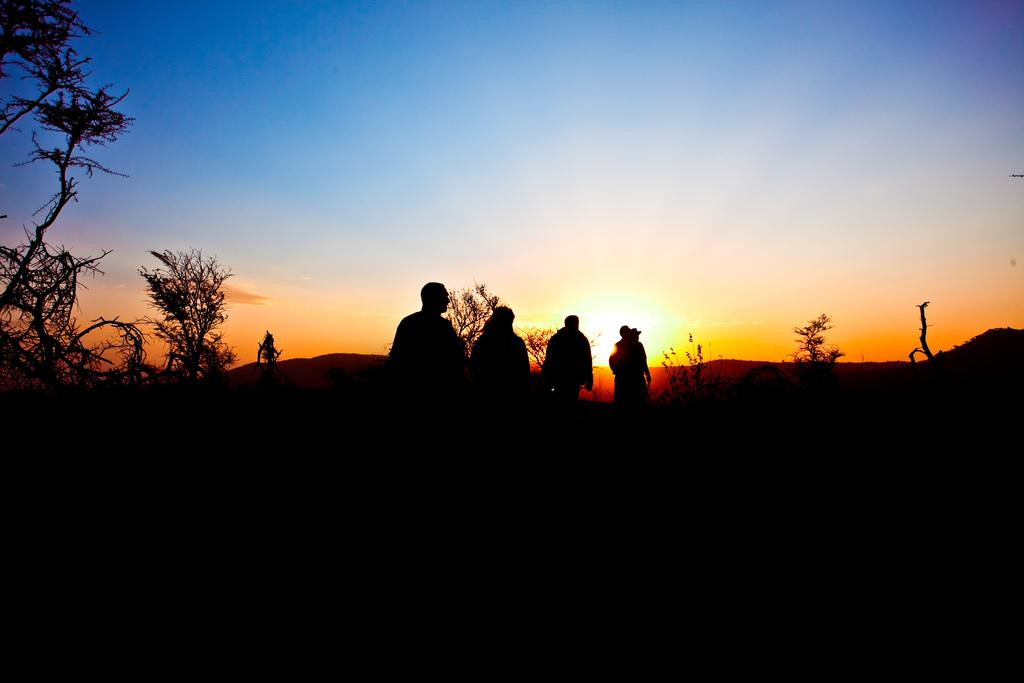How many people are standing in the image? There are four people standing in the image. What can be seen in the background of the image? The sky is visible in the image, and there appears to be an object that looks like the sun. What type of vegetation is present in the image? There are plants and trees in the image. How much dust can be seen on the house in the image? There is no house present in the image, so it is not possible to determine the amount of dust on it. 